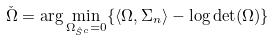<formula> <loc_0><loc_0><loc_500><loc_500>\check { \Omega } = \arg \min _ { \Omega _ { \hat { S } ^ { c } } = 0 } \{ \langle \Omega , \Sigma _ { n } \rangle - \log \det ( \Omega ) \}</formula> 